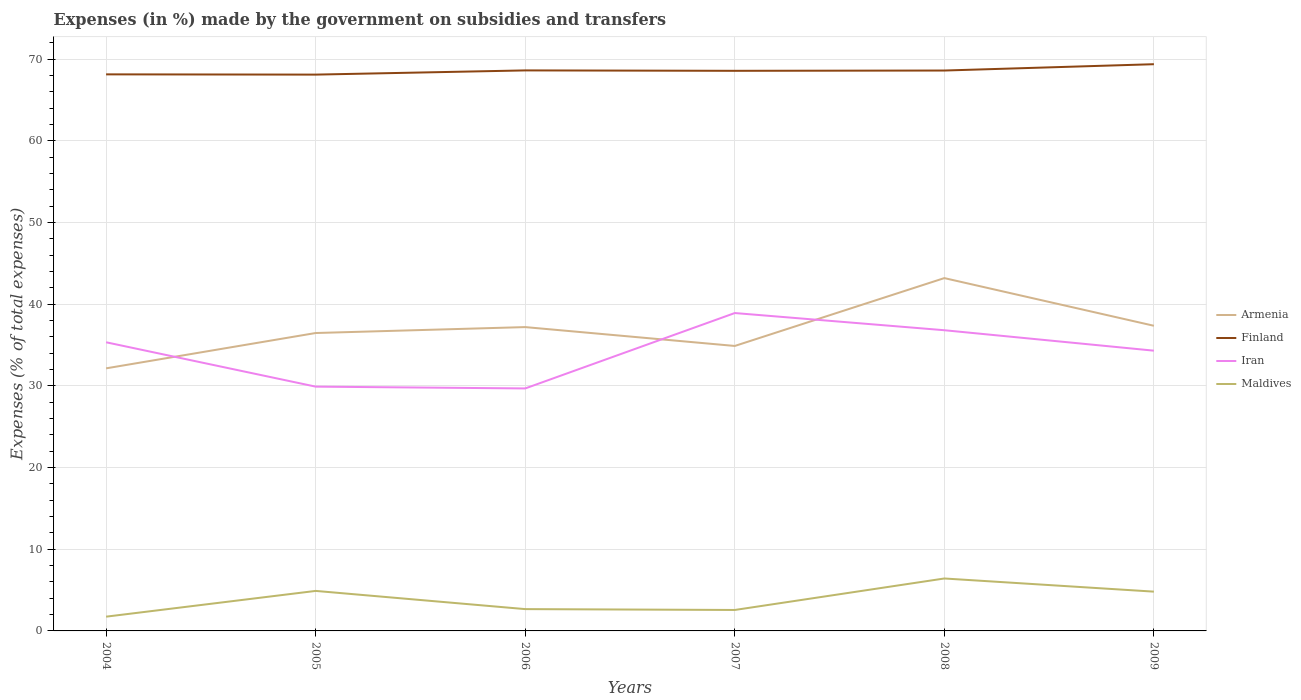Is the number of lines equal to the number of legend labels?
Give a very brief answer. Yes. Across all years, what is the maximum percentage of expenses made by the government on subsidies and transfers in Maldives?
Make the answer very short. 1.75. In which year was the percentage of expenses made by the government on subsidies and transfers in Finland maximum?
Offer a very short reply. 2005. What is the total percentage of expenses made by the government on subsidies and transfers in Iran in the graph?
Offer a terse response. -3.58. What is the difference between the highest and the second highest percentage of expenses made by the government on subsidies and transfers in Armenia?
Ensure brevity in your answer.  11.05. Is the percentage of expenses made by the government on subsidies and transfers in Armenia strictly greater than the percentage of expenses made by the government on subsidies and transfers in Finland over the years?
Your answer should be compact. Yes. What is the difference between two consecutive major ticks on the Y-axis?
Provide a short and direct response. 10. Does the graph contain grids?
Ensure brevity in your answer.  Yes. Where does the legend appear in the graph?
Your response must be concise. Center right. How many legend labels are there?
Make the answer very short. 4. How are the legend labels stacked?
Provide a short and direct response. Vertical. What is the title of the graph?
Give a very brief answer. Expenses (in %) made by the government on subsidies and transfers. Does "Mongolia" appear as one of the legend labels in the graph?
Your answer should be compact. No. What is the label or title of the X-axis?
Make the answer very short. Years. What is the label or title of the Y-axis?
Make the answer very short. Expenses (% of total expenses). What is the Expenses (% of total expenses) of Armenia in 2004?
Offer a terse response. 32.15. What is the Expenses (% of total expenses) in Finland in 2004?
Offer a very short reply. 68.15. What is the Expenses (% of total expenses) of Iran in 2004?
Your answer should be very brief. 35.34. What is the Expenses (% of total expenses) in Maldives in 2004?
Keep it short and to the point. 1.75. What is the Expenses (% of total expenses) of Armenia in 2005?
Provide a short and direct response. 36.48. What is the Expenses (% of total expenses) of Finland in 2005?
Keep it short and to the point. 68.12. What is the Expenses (% of total expenses) in Iran in 2005?
Make the answer very short. 29.91. What is the Expenses (% of total expenses) of Maldives in 2005?
Keep it short and to the point. 4.9. What is the Expenses (% of total expenses) of Armenia in 2006?
Your response must be concise. 37.2. What is the Expenses (% of total expenses) of Finland in 2006?
Your answer should be very brief. 68.64. What is the Expenses (% of total expenses) of Iran in 2006?
Offer a terse response. 29.69. What is the Expenses (% of total expenses) of Maldives in 2006?
Provide a short and direct response. 2.67. What is the Expenses (% of total expenses) in Armenia in 2007?
Offer a terse response. 34.89. What is the Expenses (% of total expenses) of Finland in 2007?
Make the answer very short. 68.59. What is the Expenses (% of total expenses) in Iran in 2007?
Keep it short and to the point. 38.93. What is the Expenses (% of total expenses) of Maldives in 2007?
Provide a short and direct response. 2.57. What is the Expenses (% of total expenses) of Armenia in 2008?
Your response must be concise. 43.2. What is the Expenses (% of total expenses) of Finland in 2008?
Give a very brief answer. 68.62. What is the Expenses (% of total expenses) of Iran in 2008?
Ensure brevity in your answer.  36.82. What is the Expenses (% of total expenses) in Maldives in 2008?
Offer a very short reply. 6.42. What is the Expenses (% of total expenses) in Armenia in 2009?
Give a very brief answer. 37.37. What is the Expenses (% of total expenses) of Finland in 2009?
Ensure brevity in your answer.  69.4. What is the Expenses (% of total expenses) of Iran in 2009?
Offer a terse response. 34.32. What is the Expenses (% of total expenses) of Maldives in 2009?
Your response must be concise. 4.81. Across all years, what is the maximum Expenses (% of total expenses) of Armenia?
Make the answer very short. 43.2. Across all years, what is the maximum Expenses (% of total expenses) in Finland?
Your response must be concise. 69.4. Across all years, what is the maximum Expenses (% of total expenses) in Iran?
Give a very brief answer. 38.93. Across all years, what is the maximum Expenses (% of total expenses) of Maldives?
Make the answer very short. 6.42. Across all years, what is the minimum Expenses (% of total expenses) in Armenia?
Offer a terse response. 32.15. Across all years, what is the minimum Expenses (% of total expenses) of Finland?
Your answer should be very brief. 68.12. Across all years, what is the minimum Expenses (% of total expenses) in Iran?
Provide a short and direct response. 29.69. Across all years, what is the minimum Expenses (% of total expenses) of Maldives?
Offer a terse response. 1.75. What is the total Expenses (% of total expenses) of Armenia in the graph?
Offer a very short reply. 221.3. What is the total Expenses (% of total expenses) in Finland in the graph?
Offer a terse response. 411.51. What is the total Expenses (% of total expenses) of Iran in the graph?
Your answer should be very brief. 205.01. What is the total Expenses (% of total expenses) in Maldives in the graph?
Your answer should be very brief. 23.11. What is the difference between the Expenses (% of total expenses) of Armenia in 2004 and that in 2005?
Your answer should be compact. -4.33. What is the difference between the Expenses (% of total expenses) in Finland in 2004 and that in 2005?
Keep it short and to the point. 0.03. What is the difference between the Expenses (% of total expenses) in Iran in 2004 and that in 2005?
Your answer should be very brief. 5.43. What is the difference between the Expenses (% of total expenses) of Maldives in 2004 and that in 2005?
Give a very brief answer. -3.15. What is the difference between the Expenses (% of total expenses) in Armenia in 2004 and that in 2006?
Keep it short and to the point. -5.05. What is the difference between the Expenses (% of total expenses) of Finland in 2004 and that in 2006?
Give a very brief answer. -0.48. What is the difference between the Expenses (% of total expenses) of Iran in 2004 and that in 2006?
Your answer should be compact. 5.65. What is the difference between the Expenses (% of total expenses) of Maldives in 2004 and that in 2006?
Offer a very short reply. -0.92. What is the difference between the Expenses (% of total expenses) of Armenia in 2004 and that in 2007?
Offer a very short reply. -2.74. What is the difference between the Expenses (% of total expenses) in Finland in 2004 and that in 2007?
Your response must be concise. -0.43. What is the difference between the Expenses (% of total expenses) in Iran in 2004 and that in 2007?
Keep it short and to the point. -3.58. What is the difference between the Expenses (% of total expenses) of Maldives in 2004 and that in 2007?
Your response must be concise. -0.82. What is the difference between the Expenses (% of total expenses) of Armenia in 2004 and that in 2008?
Keep it short and to the point. -11.05. What is the difference between the Expenses (% of total expenses) in Finland in 2004 and that in 2008?
Keep it short and to the point. -0.47. What is the difference between the Expenses (% of total expenses) of Iran in 2004 and that in 2008?
Ensure brevity in your answer.  -1.48. What is the difference between the Expenses (% of total expenses) of Maldives in 2004 and that in 2008?
Your answer should be compact. -4.67. What is the difference between the Expenses (% of total expenses) in Armenia in 2004 and that in 2009?
Your answer should be compact. -5.21. What is the difference between the Expenses (% of total expenses) of Finland in 2004 and that in 2009?
Ensure brevity in your answer.  -1.24. What is the difference between the Expenses (% of total expenses) of Iran in 2004 and that in 2009?
Make the answer very short. 1.03. What is the difference between the Expenses (% of total expenses) of Maldives in 2004 and that in 2009?
Offer a terse response. -3.06. What is the difference between the Expenses (% of total expenses) of Armenia in 2005 and that in 2006?
Your answer should be very brief. -0.73. What is the difference between the Expenses (% of total expenses) in Finland in 2005 and that in 2006?
Ensure brevity in your answer.  -0.52. What is the difference between the Expenses (% of total expenses) in Iran in 2005 and that in 2006?
Your answer should be compact. 0.22. What is the difference between the Expenses (% of total expenses) in Maldives in 2005 and that in 2006?
Ensure brevity in your answer.  2.23. What is the difference between the Expenses (% of total expenses) of Armenia in 2005 and that in 2007?
Make the answer very short. 1.58. What is the difference between the Expenses (% of total expenses) in Finland in 2005 and that in 2007?
Give a very brief answer. -0.47. What is the difference between the Expenses (% of total expenses) of Iran in 2005 and that in 2007?
Ensure brevity in your answer.  -9.01. What is the difference between the Expenses (% of total expenses) in Maldives in 2005 and that in 2007?
Keep it short and to the point. 2.33. What is the difference between the Expenses (% of total expenses) in Armenia in 2005 and that in 2008?
Provide a succinct answer. -6.72. What is the difference between the Expenses (% of total expenses) in Finland in 2005 and that in 2008?
Your answer should be very brief. -0.5. What is the difference between the Expenses (% of total expenses) of Iran in 2005 and that in 2008?
Make the answer very short. -6.91. What is the difference between the Expenses (% of total expenses) of Maldives in 2005 and that in 2008?
Your answer should be compact. -1.52. What is the difference between the Expenses (% of total expenses) of Armenia in 2005 and that in 2009?
Offer a terse response. -0.89. What is the difference between the Expenses (% of total expenses) in Finland in 2005 and that in 2009?
Your response must be concise. -1.28. What is the difference between the Expenses (% of total expenses) in Iran in 2005 and that in 2009?
Provide a succinct answer. -4.4. What is the difference between the Expenses (% of total expenses) in Maldives in 2005 and that in 2009?
Offer a very short reply. 0.09. What is the difference between the Expenses (% of total expenses) of Armenia in 2006 and that in 2007?
Your answer should be very brief. 2.31. What is the difference between the Expenses (% of total expenses) in Finland in 2006 and that in 2007?
Your answer should be compact. 0.05. What is the difference between the Expenses (% of total expenses) of Iran in 2006 and that in 2007?
Give a very brief answer. -9.23. What is the difference between the Expenses (% of total expenses) of Maldives in 2006 and that in 2007?
Your answer should be compact. 0.11. What is the difference between the Expenses (% of total expenses) of Armenia in 2006 and that in 2008?
Offer a terse response. -6. What is the difference between the Expenses (% of total expenses) of Finland in 2006 and that in 2008?
Give a very brief answer. 0.01. What is the difference between the Expenses (% of total expenses) in Iran in 2006 and that in 2008?
Give a very brief answer. -7.13. What is the difference between the Expenses (% of total expenses) of Maldives in 2006 and that in 2008?
Make the answer very short. -3.75. What is the difference between the Expenses (% of total expenses) of Armenia in 2006 and that in 2009?
Keep it short and to the point. -0.16. What is the difference between the Expenses (% of total expenses) in Finland in 2006 and that in 2009?
Ensure brevity in your answer.  -0.76. What is the difference between the Expenses (% of total expenses) of Iran in 2006 and that in 2009?
Your response must be concise. -4.62. What is the difference between the Expenses (% of total expenses) in Maldives in 2006 and that in 2009?
Provide a short and direct response. -2.14. What is the difference between the Expenses (% of total expenses) in Armenia in 2007 and that in 2008?
Make the answer very short. -8.31. What is the difference between the Expenses (% of total expenses) in Finland in 2007 and that in 2008?
Provide a succinct answer. -0.03. What is the difference between the Expenses (% of total expenses) of Iran in 2007 and that in 2008?
Provide a succinct answer. 2.1. What is the difference between the Expenses (% of total expenses) of Maldives in 2007 and that in 2008?
Your answer should be very brief. -3.86. What is the difference between the Expenses (% of total expenses) of Armenia in 2007 and that in 2009?
Your response must be concise. -2.47. What is the difference between the Expenses (% of total expenses) in Finland in 2007 and that in 2009?
Ensure brevity in your answer.  -0.81. What is the difference between the Expenses (% of total expenses) of Iran in 2007 and that in 2009?
Your response must be concise. 4.61. What is the difference between the Expenses (% of total expenses) in Maldives in 2007 and that in 2009?
Ensure brevity in your answer.  -2.24. What is the difference between the Expenses (% of total expenses) of Armenia in 2008 and that in 2009?
Offer a terse response. 5.84. What is the difference between the Expenses (% of total expenses) in Finland in 2008 and that in 2009?
Your answer should be compact. -0.78. What is the difference between the Expenses (% of total expenses) in Iran in 2008 and that in 2009?
Offer a terse response. 2.5. What is the difference between the Expenses (% of total expenses) in Maldives in 2008 and that in 2009?
Your answer should be very brief. 1.61. What is the difference between the Expenses (% of total expenses) in Armenia in 2004 and the Expenses (% of total expenses) in Finland in 2005?
Provide a succinct answer. -35.97. What is the difference between the Expenses (% of total expenses) of Armenia in 2004 and the Expenses (% of total expenses) of Iran in 2005?
Make the answer very short. 2.24. What is the difference between the Expenses (% of total expenses) in Armenia in 2004 and the Expenses (% of total expenses) in Maldives in 2005?
Your response must be concise. 27.25. What is the difference between the Expenses (% of total expenses) in Finland in 2004 and the Expenses (% of total expenses) in Iran in 2005?
Offer a very short reply. 38.24. What is the difference between the Expenses (% of total expenses) of Finland in 2004 and the Expenses (% of total expenses) of Maldives in 2005?
Provide a succinct answer. 63.25. What is the difference between the Expenses (% of total expenses) in Iran in 2004 and the Expenses (% of total expenses) in Maldives in 2005?
Keep it short and to the point. 30.45. What is the difference between the Expenses (% of total expenses) in Armenia in 2004 and the Expenses (% of total expenses) in Finland in 2006?
Your answer should be very brief. -36.48. What is the difference between the Expenses (% of total expenses) of Armenia in 2004 and the Expenses (% of total expenses) of Iran in 2006?
Your response must be concise. 2.46. What is the difference between the Expenses (% of total expenses) in Armenia in 2004 and the Expenses (% of total expenses) in Maldives in 2006?
Offer a terse response. 29.48. What is the difference between the Expenses (% of total expenses) of Finland in 2004 and the Expenses (% of total expenses) of Iran in 2006?
Your answer should be very brief. 38.46. What is the difference between the Expenses (% of total expenses) in Finland in 2004 and the Expenses (% of total expenses) in Maldives in 2006?
Provide a succinct answer. 65.48. What is the difference between the Expenses (% of total expenses) of Iran in 2004 and the Expenses (% of total expenses) of Maldives in 2006?
Your answer should be compact. 32.67. What is the difference between the Expenses (% of total expenses) of Armenia in 2004 and the Expenses (% of total expenses) of Finland in 2007?
Offer a very short reply. -36.43. What is the difference between the Expenses (% of total expenses) in Armenia in 2004 and the Expenses (% of total expenses) in Iran in 2007?
Ensure brevity in your answer.  -6.77. What is the difference between the Expenses (% of total expenses) in Armenia in 2004 and the Expenses (% of total expenses) in Maldives in 2007?
Offer a very short reply. 29.59. What is the difference between the Expenses (% of total expenses) in Finland in 2004 and the Expenses (% of total expenses) in Iran in 2007?
Your answer should be very brief. 29.23. What is the difference between the Expenses (% of total expenses) of Finland in 2004 and the Expenses (% of total expenses) of Maldives in 2007?
Provide a short and direct response. 65.59. What is the difference between the Expenses (% of total expenses) in Iran in 2004 and the Expenses (% of total expenses) in Maldives in 2007?
Provide a short and direct response. 32.78. What is the difference between the Expenses (% of total expenses) of Armenia in 2004 and the Expenses (% of total expenses) of Finland in 2008?
Give a very brief answer. -36.47. What is the difference between the Expenses (% of total expenses) of Armenia in 2004 and the Expenses (% of total expenses) of Iran in 2008?
Offer a very short reply. -4.67. What is the difference between the Expenses (% of total expenses) of Armenia in 2004 and the Expenses (% of total expenses) of Maldives in 2008?
Keep it short and to the point. 25.73. What is the difference between the Expenses (% of total expenses) in Finland in 2004 and the Expenses (% of total expenses) in Iran in 2008?
Make the answer very short. 31.33. What is the difference between the Expenses (% of total expenses) in Finland in 2004 and the Expenses (% of total expenses) in Maldives in 2008?
Keep it short and to the point. 61.73. What is the difference between the Expenses (% of total expenses) in Iran in 2004 and the Expenses (% of total expenses) in Maldives in 2008?
Provide a succinct answer. 28.92. What is the difference between the Expenses (% of total expenses) in Armenia in 2004 and the Expenses (% of total expenses) in Finland in 2009?
Offer a terse response. -37.24. What is the difference between the Expenses (% of total expenses) in Armenia in 2004 and the Expenses (% of total expenses) in Iran in 2009?
Provide a succinct answer. -2.16. What is the difference between the Expenses (% of total expenses) in Armenia in 2004 and the Expenses (% of total expenses) in Maldives in 2009?
Your answer should be very brief. 27.34. What is the difference between the Expenses (% of total expenses) of Finland in 2004 and the Expenses (% of total expenses) of Iran in 2009?
Provide a short and direct response. 33.83. What is the difference between the Expenses (% of total expenses) in Finland in 2004 and the Expenses (% of total expenses) in Maldives in 2009?
Your answer should be very brief. 63.34. What is the difference between the Expenses (% of total expenses) in Iran in 2004 and the Expenses (% of total expenses) in Maldives in 2009?
Give a very brief answer. 30.53. What is the difference between the Expenses (% of total expenses) in Armenia in 2005 and the Expenses (% of total expenses) in Finland in 2006?
Ensure brevity in your answer.  -32.16. What is the difference between the Expenses (% of total expenses) of Armenia in 2005 and the Expenses (% of total expenses) of Iran in 2006?
Offer a very short reply. 6.79. What is the difference between the Expenses (% of total expenses) of Armenia in 2005 and the Expenses (% of total expenses) of Maldives in 2006?
Provide a short and direct response. 33.81. What is the difference between the Expenses (% of total expenses) of Finland in 2005 and the Expenses (% of total expenses) of Iran in 2006?
Give a very brief answer. 38.43. What is the difference between the Expenses (% of total expenses) in Finland in 2005 and the Expenses (% of total expenses) in Maldives in 2006?
Keep it short and to the point. 65.45. What is the difference between the Expenses (% of total expenses) in Iran in 2005 and the Expenses (% of total expenses) in Maldives in 2006?
Your answer should be very brief. 27.24. What is the difference between the Expenses (% of total expenses) in Armenia in 2005 and the Expenses (% of total expenses) in Finland in 2007?
Make the answer very short. -32.11. What is the difference between the Expenses (% of total expenses) of Armenia in 2005 and the Expenses (% of total expenses) of Iran in 2007?
Provide a succinct answer. -2.45. What is the difference between the Expenses (% of total expenses) in Armenia in 2005 and the Expenses (% of total expenses) in Maldives in 2007?
Your answer should be compact. 33.91. What is the difference between the Expenses (% of total expenses) in Finland in 2005 and the Expenses (% of total expenses) in Iran in 2007?
Offer a terse response. 29.19. What is the difference between the Expenses (% of total expenses) in Finland in 2005 and the Expenses (% of total expenses) in Maldives in 2007?
Ensure brevity in your answer.  65.55. What is the difference between the Expenses (% of total expenses) in Iran in 2005 and the Expenses (% of total expenses) in Maldives in 2007?
Ensure brevity in your answer.  27.35. What is the difference between the Expenses (% of total expenses) of Armenia in 2005 and the Expenses (% of total expenses) of Finland in 2008?
Provide a short and direct response. -32.14. What is the difference between the Expenses (% of total expenses) in Armenia in 2005 and the Expenses (% of total expenses) in Iran in 2008?
Provide a succinct answer. -0.34. What is the difference between the Expenses (% of total expenses) in Armenia in 2005 and the Expenses (% of total expenses) in Maldives in 2008?
Make the answer very short. 30.06. What is the difference between the Expenses (% of total expenses) in Finland in 2005 and the Expenses (% of total expenses) in Iran in 2008?
Provide a short and direct response. 31.3. What is the difference between the Expenses (% of total expenses) of Finland in 2005 and the Expenses (% of total expenses) of Maldives in 2008?
Provide a short and direct response. 61.7. What is the difference between the Expenses (% of total expenses) in Iran in 2005 and the Expenses (% of total expenses) in Maldives in 2008?
Offer a very short reply. 23.49. What is the difference between the Expenses (% of total expenses) in Armenia in 2005 and the Expenses (% of total expenses) in Finland in 2009?
Make the answer very short. -32.92. What is the difference between the Expenses (% of total expenses) of Armenia in 2005 and the Expenses (% of total expenses) of Iran in 2009?
Your answer should be compact. 2.16. What is the difference between the Expenses (% of total expenses) in Armenia in 2005 and the Expenses (% of total expenses) in Maldives in 2009?
Your response must be concise. 31.67. What is the difference between the Expenses (% of total expenses) of Finland in 2005 and the Expenses (% of total expenses) of Iran in 2009?
Your answer should be compact. 33.8. What is the difference between the Expenses (% of total expenses) of Finland in 2005 and the Expenses (% of total expenses) of Maldives in 2009?
Provide a succinct answer. 63.31. What is the difference between the Expenses (% of total expenses) in Iran in 2005 and the Expenses (% of total expenses) in Maldives in 2009?
Offer a very short reply. 25.1. What is the difference between the Expenses (% of total expenses) in Armenia in 2006 and the Expenses (% of total expenses) in Finland in 2007?
Provide a short and direct response. -31.38. What is the difference between the Expenses (% of total expenses) in Armenia in 2006 and the Expenses (% of total expenses) in Iran in 2007?
Your answer should be compact. -1.72. What is the difference between the Expenses (% of total expenses) of Armenia in 2006 and the Expenses (% of total expenses) of Maldives in 2007?
Make the answer very short. 34.64. What is the difference between the Expenses (% of total expenses) in Finland in 2006 and the Expenses (% of total expenses) in Iran in 2007?
Make the answer very short. 29.71. What is the difference between the Expenses (% of total expenses) in Finland in 2006 and the Expenses (% of total expenses) in Maldives in 2007?
Keep it short and to the point. 66.07. What is the difference between the Expenses (% of total expenses) of Iran in 2006 and the Expenses (% of total expenses) of Maldives in 2007?
Your answer should be compact. 27.13. What is the difference between the Expenses (% of total expenses) of Armenia in 2006 and the Expenses (% of total expenses) of Finland in 2008?
Provide a succinct answer. -31.42. What is the difference between the Expenses (% of total expenses) of Armenia in 2006 and the Expenses (% of total expenses) of Iran in 2008?
Provide a succinct answer. 0.38. What is the difference between the Expenses (% of total expenses) of Armenia in 2006 and the Expenses (% of total expenses) of Maldives in 2008?
Your answer should be very brief. 30.78. What is the difference between the Expenses (% of total expenses) of Finland in 2006 and the Expenses (% of total expenses) of Iran in 2008?
Provide a succinct answer. 31.81. What is the difference between the Expenses (% of total expenses) of Finland in 2006 and the Expenses (% of total expenses) of Maldives in 2008?
Offer a very short reply. 62.21. What is the difference between the Expenses (% of total expenses) in Iran in 2006 and the Expenses (% of total expenses) in Maldives in 2008?
Offer a terse response. 23.27. What is the difference between the Expenses (% of total expenses) of Armenia in 2006 and the Expenses (% of total expenses) of Finland in 2009?
Make the answer very short. -32.19. What is the difference between the Expenses (% of total expenses) in Armenia in 2006 and the Expenses (% of total expenses) in Iran in 2009?
Your response must be concise. 2.89. What is the difference between the Expenses (% of total expenses) of Armenia in 2006 and the Expenses (% of total expenses) of Maldives in 2009?
Give a very brief answer. 32.39. What is the difference between the Expenses (% of total expenses) of Finland in 2006 and the Expenses (% of total expenses) of Iran in 2009?
Your answer should be very brief. 34.32. What is the difference between the Expenses (% of total expenses) of Finland in 2006 and the Expenses (% of total expenses) of Maldives in 2009?
Give a very brief answer. 63.83. What is the difference between the Expenses (% of total expenses) in Iran in 2006 and the Expenses (% of total expenses) in Maldives in 2009?
Your answer should be very brief. 24.88. What is the difference between the Expenses (% of total expenses) in Armenia in 2007 and the Expenses (% of total expenses) in Finland in 2008?
Provide a succinct answer. -33.73. What is the difference between the Expenses (% of total expenses) of Armenia in 2007 and the Expenses (% of total expenses) of Iran in 2008?
Your answer should be compact. -1.93. What is the difference between the Expenses (% of total expenses) of Armenia in 2007 and the Expenses (% of total expenses) of Maldives in 2008?
Keep it short and to the point. 28.47. What is the difference between the Expenses (% of total expenses) of Finland in 2007 and the Expenses (% of total expenses) of Iran in 2008?
Make the answer very short. 31.77. What is the difference between the Expenses (% of total expenses) of Finland in 2007 and the Expenses (% of total expenses) of Maldives in 2008?
Your answer should be very brief. 62.16. What is the difference between the Expenses (% of total expenses) in Iran in 2007 and the Expenses (% of total expenses) in Maldives in 2008?
Provide a succinct answer. 32.5. What is the difference between the Expenses (% of total expenses) in Armenia in 2007 and the Expenses (% of total expenses) in Finland in 2009?
Ensure brevity in your answer.  -34.5. What is the difference between the Expenses (% of total expenses) in Armenia in 2007 and the Expenses (% of total expenses) in Iran in 2009?
Your answer should be very brief. 0.58. What is the difference between the Expenses (% of total expenses) of Armenia in 2007 and the Expenses (% of total expenses) of Maldives in 2009?
Provide a succinct answer. 30.08. What is the difference between the Expenses (% of total expenses) of Finland in 2007 and the Expenses (% of total expenses) of Iran in 2009?
Make the answer very short. 34.27. What is the difference between the Expenses (% of total expenses) of Finland in 2007 and the Expenses (% of total expenses) of Maldives in 2009?
Keep it short and to the point. 63.78. What is the difference between the Expenses (% of total expenses) in Iran in 2007 and the Expenses (% of total expenses) in Maldives in 2009?
Your answer should be compact. 34.12. What is the difference between the Expenses (% of total expenses) of Armenia in 2008 and the Expenses (% of total expenses) of Finland in 2009?
Your response must be concise. -26.19. What is the difference between the Expenses (% of total expenses) of Armenia in 2008 and the Expenses (% of total expenses) of Iran in 2009?
Your response must be concise. 8.89. What is the difference between the Expenses (% of total expenses) in Armenia in 2008 and the Expenses (% of total expenses) in Maldives in 2009?
Make the answer very short. 38.39. What is the difference between the Expenses (% of total expenses) in Finland in 2008 and the Expenses (% of total expenses) in Iran in 2009?
Offer a terse response. 34.3. What is the difference between the Expenses (% of total expenses) of Finland in 2008 and the Expenses (% of total expenses) of Maldives in 2009?
Your answer should be very brief. 63.81. What is the difference between the Expenses (% of total expenses) in Iran in 2008 and the Expenses (% of total expenses) in Maldives in 2009?
Provide a short and direct response. 32.01. What is the average Expenses (% of total expenses) of Armenia per year?
Provide a short and direct response. 36.88. What is the average Expenses (% of total expenses) in Finland per year?
Provide a short and direct response. 68.58. What is the average Expenses (% of total expenses) in Iran per year?
Offer a very short reply. 34.17. What is the average Expenses (% of total expenses) in Maldives per year?
Your answer should be compact. 3.85. In the year 2004, what is the difference between the Expenses (% of total expenses) of Armenia and Expenses (% of total expenses) of Finland?
Offer a terse response. -36. In the year 2004, what is the difference between the Expenses (% of total expenses) in Armenia and Expenses (% of total expenses) in Iran?
Ensure brevity in your answer.  -3.19. In the year 2004, what is the difference between the Expenses (% of total expenses) in Armenia and Expenses (% of total expenses) in Maldives?
Offer a terse response. 30.41. In the year 2004, what is the difference between the Expenses (% of total expenses) of Finland and Expenses (% of total expenses) of Iran?
Provide a succinct answer. 32.81. In the year 2004, what is the difference between the Expenses (% of total expenses) of Finland and Expenses (% of total expenses) of Maldives?
Offer a terse response. 66.4. In the year 2004, what is the difference between the Expenses (% of total expenses) in Iran and Expenses (% of total expenses) in Maldives?
Provide a short and direct response. 33.6. In the year 2005, what is the difference between the Expenses (% of total expenses) of Armenia and Expenses (% of total expenses) of Finland?
Give a very brief answer. -31.64. In the year 2005, what is the difference between the Expenses (% of total expenses) in Armenia and Expenses (% of total expenses) in Iran?
Offer a terse response. 6.57. In the year 2005, what is the difference between the Expenses (% of total expenses) of Armenia and Expenses (% of total expenses) of Maldives?
Make the answer very short. 31.58. In the year 2005, what is the difference between the Expenses (% of total expenses) of Finland and Expenses (% of total expenses) of Iran?
Your answer should be compact. 38.21. In the year 2005, what is the difference between the Expenses (% of total expenses) of Finland and Expenses (% of total expenses) of Maldives?
Make the answer very short. 63.22. In the year 2005, what is the difference between the Expenses (% of total expenses) in Iran and Expenses (% of total expenses) in Maldives?
Ensure brevity in your answer.  25.01. In the year 2006, what is the difference between the Expenses (% of total expenses) in Armenia and Expenses (% of total expenses) in Finland?
Your response must be concise. -31.43. In the year 2006, what is the difference between the Expenses (% of total expenses) of Armenia and Expenses (% of total expenses) of Iran?
Offer a very short reply. 7.51. In the year 2006, what is the difference between the Expenses (% of total expenses) of Armenia and Expenses (% of total expenses) of Maldives?
Provide a short and direct response. 34.53. In the year 2006, what is the difference between the Expenses (% of total expenses) of Finland and Expenses (% of total expenses) of Iran?
Ensure brevity in your answer.  38.94. In the year 2006, what is the difference between the Expenses (% of total expenses) in Finland and Expenses (% of total expenses) in Maldives?
Ensure brevity in your answer.  65.96. In the year 2006, what is the difference between the Expenses (% of total expenses) in Iran and Expenses (% of total expenses) in Maldives?
Keep it short and to the point. 27.02. In the year 2007, what is the difference between the Expenses (% of total expenses) in Armenia and Expenses (% of total expenses) in Finland?
Provide a succinct answer. -33.69. In the year 2007, what is the difference between the Expenses (% of total expenses) in Armenia and Expenses (% of total expenses) in Iran?
Keep it short and to the point. -4.03. In the year 2007, what is the difference between the Expenses (% of total expenses) in Armenia and Expenses (% of total expenses) in Maldives?
Your answer should be very brief. 32.33. In the year 2007, what is the difference between the Expenses (% of total expenses) of Finland and Expenses (% of total expenses) of Iran?
Offer a terse response. 29.66. In the year 2007, what is the difference between the Expenses (% of total expenses) of Finland and Expenses (% of total expenses) of Maldives?
Offer a very short reply. 66.02. In the year 2007, what is the difference between the Expenses (% of total expenses) of Iran and Expenses (% of total expenses) of Maldives?
Provide a succinct answer. 36.36. In the year 2008, what is the difference between the Expenses (% of total expenses) of Armenia and Expenses (% of total expenses) of Finland?
Ensure brevity in your answer.  -25.42. In the year 2008, what is the difference between the Expenses (% of total expenses) in Armenia and Expenses (% of total expenses) in Iran?
Your answer should be very brief. 6.38. In the year 2008, what is the difference between the Expenses (% of total expenses) of Armenia and Expenses (% of total expenses) of Maldives?
Your response must be concise. 36.78. In the year 2008, what is the difference between the Expenses (% of total expenses) in Finland and Expenses (% of total expenses) in Iran?
Keep it short and to the point. 31.8. In the year 2008, what is the difference between the Expenses (% of total expenses) in Finland and Expenses (% of total expenses) in Maldives?
Give a very brief answer. 62.2. In the year 2008, what is the difference between the Expenses (% of total expenses) in Iran and Expenses (% of total expenses) in Maldives?
Your answer should be very brief. 30.4. In the year 2009, what is the difference between the Expenses (% of total expenses) in Armenia and Expenses (% of total expenses) in Finland?
Offer a very short reply. -32.03. In the year 2009, what is the difference between the Expenses (% of total expenses) in Armenia and Expenses (% of total expenses) in Iran?
Provide a succinct answer. 3.05. In the year 2009, what is the difference between the Expenses (% of total expenses) of Armenia and Expenses (% of total expenses) of Maldives?
Your answer should be very brief. 32.56. In the year 2009, what is the difference between the Expenses (% of total expenses) of Finland and Expenses (% of total expenses) of Iran?
Give a very brief answer. 35.08. In the year 2009, what is the difference between the Expenses (% of total expenses) of Finland and Expenses (% of total expenses) of Maldives?
Your response must be concise. 64.59. In the year 2009, what is the difference between the Expenses (% of total expenses) of Iran and Expenses (% of total expenses) of Maldives?
Keep it short and to the point. 29.51. What is the ratio of the Expenses (% of total expenses) of Armenia in 2004 to that in 2005?
Offer a very short reply. 0.88. What is the ratio of the Expenses (% of total expenses) of Finland in 2004 to that in 2005?
Offer a terse response. 1. What is the ratio of the Expenses (% of total expenses) of Iran in 2004 to that in 2005?
Ensure brevity in your answer.  1.18. What is the ratio of the Expenses (% of total expenses) of Maldives in 2004 to that in 2005?
Keep it short and to the point. 0.36. What is the ratio of the Expenses (% of total expenses) in Armenia in 2004 to that in 2006?
Provide a succinct answer. 0.86. What is the ratio of the Expenses (% of total expenses) in Finland in 2004 to that in 2006?
Give a very brief answer. 0.99. What is the ratio of the Expenses (% of total expenses) in Iran in 2004 to that in 2006?
Make the answer very short. 1.19. What is the ratio of the Expenses (% of total expenses) of Maldives in 2004 to that in 2006?
Provide a short and direct response. 0.65. What is the ratio of the Expenses (% of total expenses) in Armenia in 2004 to that in 2007?
Offer a terse response. 0.92. What is the ratio of the Expenses (% of total expenses) in Finland in 2004 to that in 2007?
Give a very brief answer. 0.99. What is the ratio of the Expenses (% of total expenses) of Iran in 2004 to that in 2007?
Provide a succinct answer. 0.91. What is the ratio of the Expenses (% of total expenses) in Maldives in 2004 to that in 2007?
Give a very brief answer. 0.68. What is the ratio of the Expenses (% of total expenses) in Armenia in 2004 to that in 2008?
Provide a short and direct response. 0.74. What is the ratio of the Expenses (% of total expenses) in Iran in 2004 to that in 2008?
Provide a succinct answer. 0.96. What is the ratio of the Expenses (% of total expenses) in Maldives in 2004 to that in 2008?
Your answer should be very brief. 0.27. What is the ratio of the Expenses (% of total expenses) in Armenia in 2004 to that in 2009?
Give a very brief answer. 0.86. What is the ratio of the Expenses (% of total expenses) of Finland in 2004 to that in 2009?
Provide a short and direct response. 0.98. What is the ratio of the Expenses (% of total expenses) of Iran in 2004 to that in 2009?
Offer a very short reply. 1.03. What is the ratio of the Expenses (% of total expenses) of Maldives in 2004 to that in 2009?
Your response must be concise. 0.36. What is the ratio of the Expenses (% of total expenses) in Armenia in 2005 to that in 2006?
Provide a succinct answer. 0.98. What is the ratio of the Expenses (% of total expenses) of Iran in 2005 to that in 2006?
Offer a very short reply. 1.01. What is the ratio of the Expenses (% of total expenses) in Maldives in 2005 to that in 2006?
Make the answer very short. 1.83. What is the ratio of the Expenses (% of total expenses) in Armenia in 2005 to that in 2007?
Give a very brief answer. 1.05. What is the ratio of the Expenses (% of total expenses) of Iran in 2005 to that in 2007?
Give a very brief answer. 0.77. What is the ratio of the Expenses (% of total expenses) in Maldives in 2005 to that in 2007?
Provide a succinct answer. 1.91. What is the ratio of the Expenses (% of total expenses) in Armenia in 2005 to that in 2008?
Provide a short and direct response. 0.84. What is the ratio of the Expenses (% of total expenses) in Iran in 2005 to that in 2008?
Ensure brevity in your answer.  0.81. What is the ratio of the Expenses (% of total expenses) of Maldives in 2005 to that in 2008?
Offer a terse response. 0.76. What is the ratio of the Expenses (% of total expenses) in Armenia in 2005 to that in 2009?
Offer a very short reply. 0.98. What is the ratio of the Expenses (% of total expenses) of Finland in 2005 to that in 2009?
Offer a terse response. 0.98. What is the ratio of the Expenses (% of total expenses) in Iran in 2005 to that in 2009?
Give a very brief answer. 0.87. What is the ratio of the Expenses (% of total expenses) in Maldives in 2005 to that in 2009?
Make the answer very short. 1.02. What is the ratio of the Expenses (% of total expenses) in Armenia in 2006 to that in 2007?
Make the answer very short. 1.07. What is the ratio of the Expenses (% of total expenses) of Finland in 2006 to that in 2007?
Provide a short and direct response. 1. What is the ratio of the Expenses (% of total expenses) in Iran in 2006 to that in 2007?
Keep it short and to the point. 0.76. What is the ratio of the Expenses (% of total expenses) in Maldives in 2006 to that in 2007?
Make the answer very short. 1.04. What is the ratio of the Expenses (% of total expenses) in Armenia in 2006 to that in 2008?
Offer a terse response. 0.86. What is the ratio of the Expenses (% of total expenses) in Iran in 2006 to that in 2008?
Ensure brevity in your answer.  0.81. What is the ratio of the Expenses (% of total expenses) in Maldives in 2006 to that in 2008?
Give a very brief answer. 0.42. What is the ratio of the Expenses (% of total expenses) of Finland in 2006 to that in 2009?
Make the answer very short. 0.99. What is the ratio of the Expenses (% of total expenses) of Iran in 2006 to that in 2009?
Your answer should be very brief. 0.87. What is the ratio of the Expenses (% of total expenses) of Maldives in 2006 to that in 2009?
Offer a very short reply. 0.56. What is the ratio of the Expenses (% of total expenses) of Armenia in 2007 to that in 2008?
Your answer should be compact. 0.81. What is the ratio of the Expenses (% of total expenses) in Finland in 2007 to that in 2008?
Your response must be concise. 1. What is the ratio of the Expenses (% of total expenses) in Iran in 2007 to that in 2008?
Ensure brevity in your answer.  1.06. What is the ratio of the Expenses (% of total expenses) of Maldives in 2007 to that in 2008?
Offer a very short reply. 0.4. What is the ratio of the Expenses (% of total expenses) of Armenia in 2007 to that in 2009?
Provide a succinct answer. 0.93. What is the ratio of the Expenses (% of total expenses) of Finland in 2007 to that in 2009?
Give a very brief answer. 0.99. What is the ratio of the Expenses (% of total expenses) in Iran in 2007 to that in 2009?
Give a very brief answer. 1.13. What is the ratio of the Expenses (% of total expenses) in Maldives in 2007 to that in 2009?
Offer a very short reply. 0.53. What is the ratio of the Expenses (% of total expenses) of Armenia in 2008 to that in 2009?
Make the answer very short. 1.16. What is the ratio of the Expenses (% of total expenses) of Finland in 2008 to that in 2009?
Offer a very short reply. 0.99. What is the ratio of the Expenses (% of total expenses) in Iran in 2008 to that in 2009?
Give a very brief answer. 1.07. What is the ratio of the Expenses (% of total expenses) of Maldives in 2008 to that in 2009?
Give a very brief answer. 1.33. What is the difference between the highest and the second highest Expenses (% of total expenses) of Armenia?
Ensure brevity in your answer.  5.84. What is the difference between the highest and the second highest Expenses (% of total expenses) in Finland?
Give a very brief answer. 0.76. What is the difference between the highest and the second highest Expenses (% of total expenses) in Iran?
Give a very brief answer. 2.1. What is the difference between the highest and the second highest Expenses (% of total expenses) of Maldives?
Your answer should be very brief. 1.52. What is the difference between the highest and the lowest Expenses (% of total expenses) in Armenia?
Provide a succinct answer. 11.05. What is the difference between the highest and the lowest Expenses (% of total expenses) in Finland?
Offer a very short reply. 1.28. What is the difference between the highest and the lowest Expenses (% of total expenses) of Iran?
Offer a terse response. 9.23. What is the difference between the highest and the lowest Expenses (% of total expenses) in Maldives?
Provide a short and direct response. 4.67. 